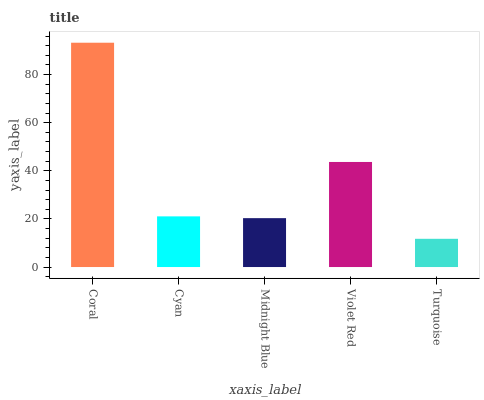Is Cyan the minimum?
Answer yes or no. No. Is Cyan the maximum?
Answer yes or no. No. Is Coral greater than Cyan?
Answer yes or no. Yes. Is Cyan less than Coral?
Answer yes or no. Yes. Is Cyan greater than Coral?
Answer yes or no. No. Is Coral less than Cyan?
Answer yes or no. No. Is Cyan the high median?
Answer yes or no. Yes. Is Cyan the low median?
Answer yes or no. Yes. Is Midnight Blue the high median?
Answer yes or no. No. Is Coral the low median?
Answer yes or no. No. 